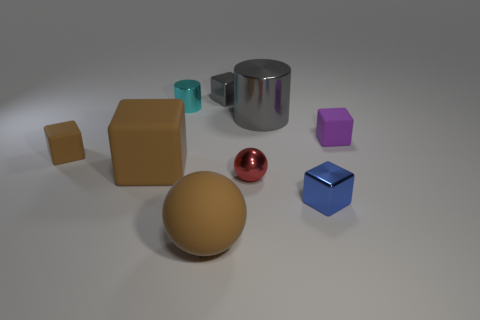Is there a rubber object of the same size as the blue metal cube?
Ensure brevity in your answer.  Yes. What is the color of the other small rubber object that is the same shape as the small brown object?
Provide a succinct answer. Purple. There is a brown rubber object that is in front of the red sphere; is it the same size as the cylinder that is on the right side of the cyan metal cylinder?
Ensure brevity in your answer.  Yes. Is there a small cyan object of the same shape as the small brown matte object?
Ensure brevity in your answer.  No. Are there the same number of purple rubber cubes that are to the left of the big gray object and tiny blue metal blocks?
Offer a very short reply. No. There is a red object; does it have the same size as the block that is right of the blue metallic block?
Keep it short and to the point. Yes. What number of tiny red things are the same material as the small gray thing?
Offer a very short reply. 1. Is the blue object the same size as the brown rubber ball?
Ensure brevity in your answer.  No. Is there anything else that is the same color as the small ball?
Give a very brief answer. No. The metallic thing that is both behind the small red shiny object and in front of the tiny cyan thing has what shape?
Make the answer very short. Cylinder. 